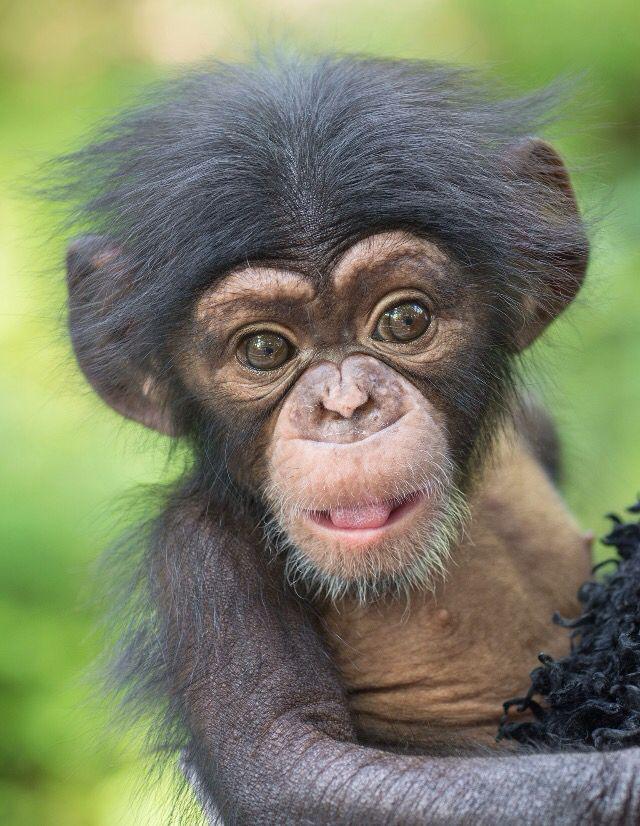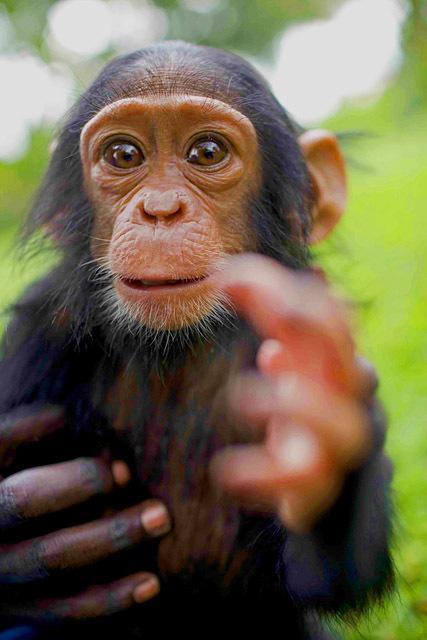The first image is the image on the left, the second image is the image on the right. For the images shown, is this caption "The monkey in one of the images is opening its mouth to reveal teeth." true? Answer yes or no. No. The first image is the image on the left, the second image is the image on the right. Given the left and right images, does the statement "Each image shows one forward-facing young chimp with a light-colored face and ears that protrude." hold true? Answer yes or no. Yes. 